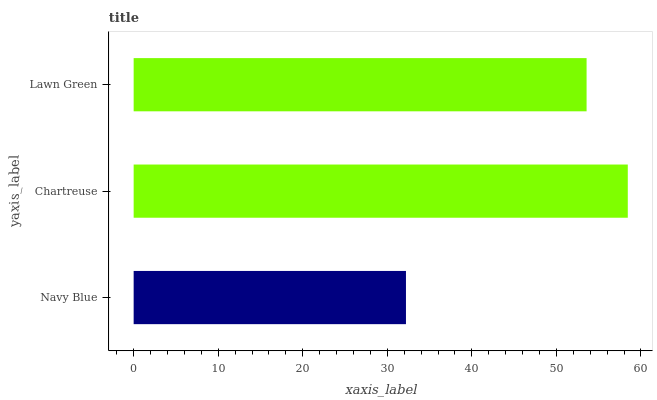Is Navy Blue the minimum?
Answer yes or no. Yes. Is Chartreuse the maximum?
Answer yes or no. Yes. Is Lawn Green the minimum?
Answer yes or no. No. Is Lawn Green the maximum?
Answer yes or no. No. Is Chartreuse greater than Lawn Green?
Answer yes or no. Yes. Is Lawn Green less than Chartreuse?
Answer yes or no. Yes. Is Lawn Green greater than Chartreuse?
Answer yes or no. No. Is Chartreuse less than Lawn Green?
Answer yes or no. No. Is Lawn Green the high median?
Answer yes or no. Yes. Is Lawn Green the low median?
Answer yes or no. Yes. Is Chartreuse the high median?
Answer yes or no. No. Is Navy Blue the low median?
Answer yes or no. No. 